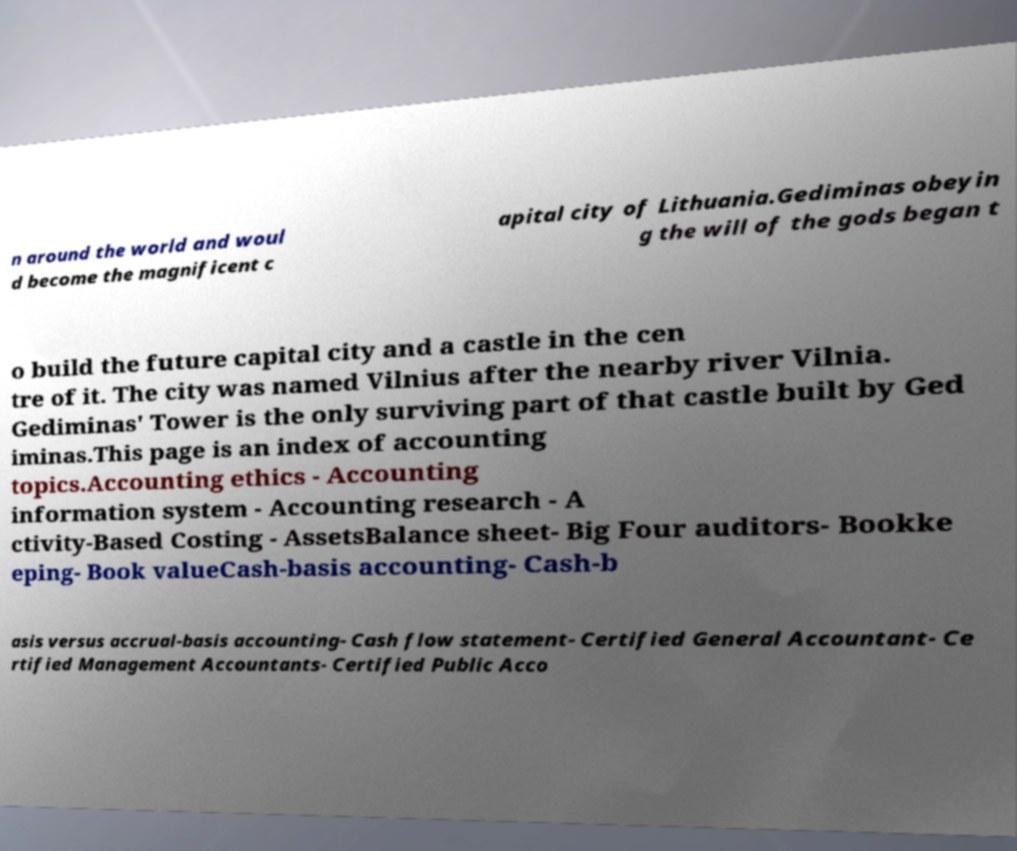Can you read and provide the text displayed in the image?This photo seems to have some interesting text. Can you extract and type it out for me? n around the world and woul d become the magnificent c apital city of Lithuania.Gediminas obeyin g the will of the gods began t o build the future capital city and a castle in the cen tre of it. The city was named Vilnius after the nearby river Vilnia. Gediminas' Tower is the only surviving part of that castle built by Ged iminas.This page is an index of accounting topics.Accounting ethics - Accounting information system - Accounting research - A ctivity-Based Costing - AssetsBalance sheet- Big Four auditors- Bookke eping- Book valueCash-basis accounting- Cash-b asis versus accrual-basis accounting- Cash flow statement- Certified General Accountant- Ce rtified Management Accountants- Certified Public Acco 